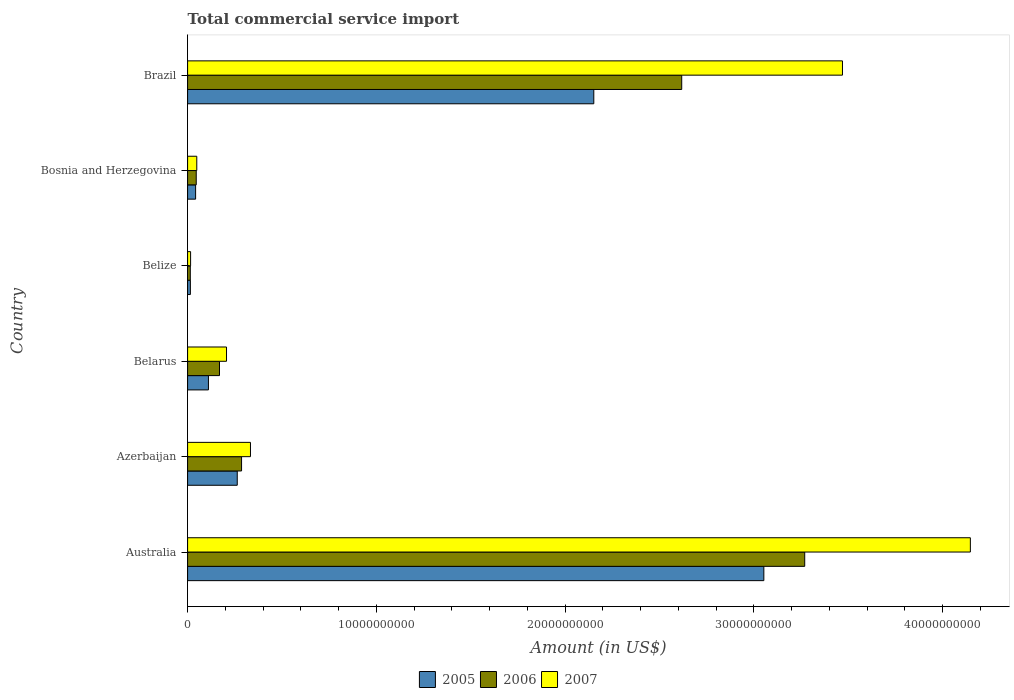How many different coloured bars are there?
Make the answer very short. 3. How many groups of bars are there?
Provide a succinct answer. 6. Are the number of bars on each tick of the Y-axis equal?
Provide a short and direct response. Yes. What is the label of the 2nd group of bars from the top?
Give a very brief answer. Bosnia and Herzegovina. What is the total commercial service import in 2007 in Brazil?
Offer a terse response. 3.47e+1. Across all countries, what is the maximum total commercial service import in 2005?
Ensure brevity in your answer.  3.05e+1. Across all countries, what is the minimum total commercial service import in 2006?
Provide a succinct answer. 1.43e+08. In which country was the total commercial service import in 2006 minimum?
Keep it short and to the point. Belize. What is the total total commercial service import in 2006 in the graph?
Offer a very short reply. 6.40e+1. What is the difference between the total commercial service import in 2005 in Azerbaijan and that in Belarus?
Provide a short and direct response. 1.53e+09. What is the difference between the total commercial service import in 2005 in Belize and the total commercial service import in 2006 in Australia?
Ensure brevity in your answer.  -3.26e+1. What is the average total commercial service import in 2005 per country?
Offer a terse response. 9.39e+09. What is the difference between the total commercial service import in 2007 and total commercial service import in 2005 in Australia?
Provide a succinct answer. 1.09e+1. What is the ratio of the total commercial service import in 2005 in Azerbaijan to that in Belarus?
Make the answer very short. 2.38. Is the total commercial service import in 2006 in Azerbaijan less than that in Bosnia and Herzegovina?
Your answer should be compact. No. What is the difference between the highest and the second highest total commercial service import in 2007?
Your answer should be compact. 6.78e+09. What is the difference between the highest and the lowest total commercial service import in 2007?
Offer a terse response. 4.13e+1. In how many countries, is the total commercial service import in 2006 greater than the average total commercial service import in 2006 taken over all countries?
Offer a terse response. 2. What does the 1st bar from the top in Azerbaijan represents?
Provide a succinct answer. 2007. What does the 3rd bar from the bottom in Bosnia and Herzegovina represents?
Offer a terse response. 2007. Is it the case that in every country, the sum of the total commercial service import in 2007 and total commercial service import in 2005 is greater than the total commercial service import in 2006?
Provide a succinct answer. Yes. How many bars are there?
Provide a short and direct response. 18. How many countries are there in the graph?
Your response must be concise. 6. Does the graph contain any zero values?
Your response must be concise. No. Does the graph contain grids?
Give a very brief answer. No. How are the legend labels stacked?
Your answer should be compact. Horizontal. What is the title of the graph?
Offer a very short reply. Total commercial service import. What is the Amount (in US$) of 2005 in Australia?
Make the answer very short. 3.05e+1. What is the Amount (in US$) in 2006 in Australia?
Your answer should be compact. 3.27e+1. What is the Amount (in US$) of 2007 in Australia?
Offer a very short reply. 4.15e+1. What is the Amount (in US$) of 2005 in Azerbaijan?
Keep it short and to the point. 2.63e+09. What is the Amount (in US$) in 2006 in Azerbaijan?
Make the answer very short. 2.86e+09. What is the Amount (in US$) of 2007 in Azerbaijan?
Provide a succinct answer. 3.33e+09. What is the Amount (in US$) of 2005 in Belarus?
Give a very brief answer. 1.10e+09. What is the Amount (in US$) in 2006 in Belarus?
Provide a short and direct response. 1.69e+09. What is the Amount (in US$) of 2007 in Belarus?
Give a very brief answer. 2.06e+09. What is the Amount (in US$) of 2005 in Belize?
Provide a short and direct response. 1.47e+08. What is the Amount (in US$) of 2006 in Belize?
Make the answer very short. 1.43e+08. What is the Amount (in US$) of 2007 in Belize?
Your answer should be compact. 1.59e+08. What is the Amount (in US$) in 2005 in Bosnia and Herzegovina?
Keep it short and to the point. 4.25e+08. What is the Amount (in US$) in 2006 in Bosnia and Herzegovina?
Offer a terse response. 4.58e+08. What is the Amount (in US$) of 2007 in Bosnia and Herzegovina?
Give a very brief answer. 4.87e+08. What is the Amount (in US$) of 2005 in Brazil?
Offer a very short reply. 2.15e+1. What is the Amount (in US$) of 2006 in Brazil?
Offer a very short reply. 2.62e+1. What is the Amount (in US$) of 2007 in Brazil?
Give a very brief answer. 3.47e+1. Across all countries, what is the maximum Amount (in US$) of 2005?
Your response must be concise. 3.05e+1. Across all countries, what is the maximum Amount (in US$) of 2006?
Ensure brevity in your answer.  3.27e+1. Across all countries, what is the maximum Amount (in US$) of 2007?
Your answer should be compact. 4.15e+1. Across all countries, what is the minimum Amount (in US$) in 2005?
Your answer should be compact. 1.47e+08. Across all countries, what is the minimum Amount (in US$) of 2006?
Your response must be concise. 1.43e+08. Across all countries, what is the minimum Amount (in US$) of 2007?
Ensure brevity in your answer.  1.59e+08. What is the total Amount (in US$) in 2005 in the graph?
Make the answer very short. 5.64e+1. What is the total Amount (in US$) in 2006 in the graph?
Ensure brevity in your answer.  6.40e+1. What is the total Amount (in US$) in 2007 in the graph?
Make the answer very short. 8.22e+1. What is the difference between the Amount (in US$) of 2005 in Australia and that in Azerbaijan?
Offer a terse response. 2.79e+1. What is the difference between the Amount (in US$) in 2006 in Australia and that in Azerbaijan?
Provide a short and direct response. 2.98e+1. What is the difference between the Amount (in US$) in 2007 in Australia and that in Azerbaijan?
Your answer should be compact. 3.81e+1. What is the difference between the Amount (in US$) in 2005 in Australia and that in Belarus?
Make the answer very short. 2.94e+1. What is the difference between the Amount (in US$) in 2006 in Australia and that in Belarus?
Ensure brevity in your answer.  3.10e+1. What is the difference between the Amount (in US$) of 2007 in Australia and that in Belarus?
Your response must be concise. 3.94e+1. What is the difference between the Amount (in US$) in 2005 in Australia and that in Belize?
Give a very brief answer. 3.04e+1. What is the difference between the Amount (in US$) of 2006 in Australia and that in Belize?
Provide a succinct answer. 3.26e+1. What is the difference between the Amount (in US$) of 2007 in Australia and that in Belize?
Offer a very short reply. 4.13e+1. What is the difference between the Amount (in US$) of 2005 in Australia and that in Bosnia and Herzegovina?
Keep it short and to the point. 3.01e+1. What is the difference between the Amount (in US$) in 2006 in Australia and that in Bosnia and Herzegovina?
Ensure brevity in your answer.  3.22e+1. What is the difference between the Amount (in US$) of 2007 in Australia and that in Bosnia and Herzegovina?
Give a very brief answer. 4.10e+1. What is the difference between the Amount (in US$) in 2005 in Australia and that in Brazil?
Offer a very short reply. 9.01e+09. What is the difference between the Amount (in US$) of 2006 in Australia and that in Brazil?
Offer a very short reply. 6.52e+09. What is the difference between the Amount (in US$) of 2007 in Australia and that in Brazil?
Offer a very short reply. 6.78e+09. What is the difference between the Amount (in US$) in 2005 in Azerbaijan and that in Belarus?
Offer a terse response. 1.53e+09. What is the difference between the Amount (in US$) in 2006 in Azerbaijan and that in Belarus?
Offer a very short reply. 1.17e+09. What is the difference between the Amount (in US$) in 2007 in Azerbaijan and that in Belarus?
Offer a very short reply. 1.27e+09. What is the difference between the Amount (in US$) in 2005 in Azerbaijan and that in Belize?
Offer a terse response. 2.48e+09. What is the difference between the Amount (in US$) in 2006 in Azerbaijan and that in Belize?
Ensure brevity in your answer.  2.72e+09. What is the difference between the Amount (in US$) in 2007 in Azerbaijan and that in Belize?
Make the answer very short. 3.17e+09. What is the difference between the Amount (in US$) of 2005 in Azerbaijan and that in Bosnia and Herzegovina?
Provide a succinct answer. 2.21e+09. What is the difference between the Amount (in US$) of 2006 in Azerbaijan and that in Bosnia and Herzegovina?
Keep it short and to the point. 2.40e+09. What is the difference between the Amount (in US$) in 2007 in Azerbaijan and that in Bosnia and Herzegovina?
Offer a very short reply. 2.84e+09. What is the difference between the Amount (in US$) in 2005 in Azerbaijan and that in Brazil?
Provide a short and direct response. -1.89e+1. What is the difference between the Amount (in US$) of 2006 in Azerbaijan and that in Brazil?
Your response must be concise. -2.33e+1. What is the difference between the Amount (in US$) in 2007 in Azerbaijan and that in Brazil?
Your answer should be compact. -3.14e+1. What is the difference between the Amount (in US$) of 2005 in Belarus and that in Belize?
Give a very brief answer. 9.57e+08. What is the difference between the Amount (in US$) of 2006 in Belarus and that in Belize?
Your answer should be very brief. 1.55e+09. What is the difference between the Amount (in US$) in 2007 in Belarus and that in Belize?
Your answer should be very brief. 1.90e+09. What is the difference between the Amount (in US$) in 2005 in Belarus and that in Bosnia and Herzegovina?
Your answer should be compact. 6.79e+08. What is the difference between the Amount (in US$) in 2006 in Belarus and that in Bosnia and Herzegovina?
Provide a succinct answer. 1.23e+09. What is the difference between the Amount (in US$) in 2007 in Belarus and that in Bosnia and Herzegovina?
Make the answer very short. 1.58e+09. What is the difference between the Amount (in US$) in 2005 in Belarus and that in Brazil?
Make the answer very short. -2.04e+1. What is the difference between the Amount (in US$) of 2006 in Belarus and that in Brazil?
Your response must be concise. -2.45e+1. What is the difference between the Amount (in US$) in 2007 in Belarus and that in Brazil?
Keep it short and to the point. -3.26e+1. What is the difference between the Amount (in US$) in 2005 in Belize and that in Bosnia and Herzegovina?
Provide a succinct answer. -2.78e+08. What is the difference between the Amount (in US$) of 2006 in Belize and that in Bosnia and Herzegovina?
Your answer should be very brief. -3.15e+08. What is the difference between the Amount (in US$) in 2007 in Belize and that in Bosnia and Herzegovina?
Ensure brevity in your answer.  -3.28e+08. What is the difference between the Amount (in US$) of 2005 in Belize and that in Brazil?
Give a very brief answer. -2.14e+1. What is the difference between the Amount (in US$) of 2006 in Belize and that in Brazil?
Offer a terse response. -2.60e+1. What is the difference between the Amount (in US$) of 2007 in Belize and that in Brazil?
Give a very brief answer. -3.45e+1. What is the difference between the Amount (in US$) of 2005 in Bosnia and Herzegovina and that in Brazil?
Keep it short and to the point. -2.11e+1. What is the difference between the Amount (in US$) in 2006 in Bosnia and Herzegovina and that in Brazil?
Ensure brevity in your answer.  -2.57e+1. What is the difference between the Amount (in US$) of 2007 in Bosnia and Herzegovina and that in Brazil?
Your response must be concise. -3.42e+1. What is the difference between the Amount (in US$) in 2005 in Australia and the Amount (in US$) in 2006 in Azerbaijan?
Your answer should be compact. 2.77e+1. What is the difference between the Amount (in US$) of 2005 in Australia and the Amount (in US$) of 2007 in Azerbaijan?
Offer a very short reply. 2.72e+1. What is the difference between the Amount (in US$) of 2006 in Australia and the Amount (in US$) of 2007 in Azerbaijan?
Your answer should be very brief. 2.94e+1. What is the difference between the Amount (in US$) in 2005 in Australia and the Amount (in US$) in 2006 in Belarus?
Your response must be concise. 2.88e+1. What is the difference between the Amount (in US$) of 2005 in Australia and the Amount (in US$) of 2007 in Belarus?
Keep it short and to the point. 2.85e+1. What is the difference between the Amount (in US$) in 2006 in Australia and the Amount (in US$) in 2007 in Belarus?
Your response must be concise. 3.06e+1. What is the difference between the Amount (in US$) in 2005 in Australia and the Amount (in US$) in 2006 in Belize?
Your answer should be compact. 3.04e+1. What is the difference between the Amount (in US$) of 2005 in Australia and the Amount (in US$) of 2007 in Belize?
Keep it short and to the point. 3.04e+1. What is the difference between the Amount (in US$) of 2006 in Australia and the Amount (in US$) of 2007 in Belize?
Your response must be concise. 3.25e+1. What is the difference between the Amount (in US$) in 2005 in Australia and the Amount (in US$) in 2006 in Bosnia and Herzegovina?
Keep it short and to the point. 3.01e+1. What is the difference between the Amount (in US$) of 2005 in Australia and the Amount (in US$) of 2007 in Bosnia and Herzegovina?
Keep it short and to the point. 3.00e+1. What is the difference between the Amount (in US$) in 2006 in Australia and the Amount (in US$) in 2007 in Bosnia and Herzegovina?
Give a very brief answer. 3.22e+1. What is the difference between the Amount (in US$) of 2005 in Australia and the Amount (in US$) of 2006 in Brazil?
Give a very brief answer. 4.35e+09. What is the difference between the Amount (in US$) in 2005 in Australia and the Amount (in US$) in 2007 in Brazil?
Offer a terse response. -4.17e+09. What is the difference between the Amount (in US$) in 2006 in Australia and the Amount (in US$) in 2007 in Brazil?
Your answer should be compact. -2.00e+09. What is the difference between the Amount (in US$) of 2005 in Azerbaijan and the Amount (in US$) of 2006 in Belarus?
Offer a very short reply. 9.40e+08. What is the difference between the Amount (in US$) in 2005 in Azerbaijan and the Amount (in US$) in 2007 in Belarus?
Your answer should be very brief. 5.68e+08. What is the difference between the Amount (in US$) in 2006 in Azerbaijan and the Amount (in US$) in 2007 in Belarus?
Offer a very short reply. 7.97e+08. What is the difference between the Amount (in US$) of 2005 in Azerbaijan and the Amount (in US$) of 2006 in Belize?
Provide a succinct answer. 2.49e+09. What is the difference between the Amount (in US$) in 2005 in Azerbaijan and the Amount (in US$) in 2007 in Belize?
Provide a succinct answer. 2.47e+09. What is the difference between the Amount (in US$) of 2006 in Azerbaijan and the Amount (in US$) of 2007 in Belize?
Provide a succinct answer. 2.70e+09. What is the difference between the Amount (in US$) of 2005 in Azerbaijan and the Amount (in US$) of 2006 in Bosnia and Herzegovina?
Your answer should be very brief. 2.17e+09. What is the difference between the Amount (in US$) in 2005 in Azerbaijan and the Amount (in US$) in 2007 in Bosnia and Herzegovina?
Offer a very short reply. 2.14e+09. What is the difference between the Amount (in US$) of 2006 in Azerbaijan and the Amount (in US$) of 2007 in Bosnia and Herzegovina?
Keep it short and to the point. 2.37e+09. What is the difference between the Amount (in US$) of 2005 in Azerbaijan and the Amount (in US$) of 2006 in Brazil?
Ensure brevity in your answer.  -2.36e+1. What is the difference between the Amount (in US$) of 2005 in Azerbaijan and the Amount (in US$) of 2007 in Brazil?
Give a very brief answer. -3.21e+1. What is the difference between the Amount (in US$) of 2006 in Azerbaijan and the Amount (in US$) of 2007 in Brazil?
Make the answer very short. -3.18e+1. What is the difference between the Amount (in US$) in 2005 in Belarus and the Amount (in US$) in 2006 in Belize?
Give a very brief answer. 9.61e+08. What is the difference between the Amount (in US$) of 2005 in Belarus and the Amount (in US$) of 2007 in Belize?
Keep it short and to the point. 9.45e+08. What is the difference between the Amount (in US$) of 2006 in Belarus and the Amount (in US$) of 2007 in Belize?
Keep it short and to the point. 1.53e+09. What is the difference between the Amount (in US$) of 2005 in Belarus and the Amount (in US$) of 2006 in Bosnia and Herzegovina?
Provide a short and direct response. 6.46e+08. What is the difference between the Amount (in US$) of 2005 in Belarus and the Amount (in US$) of 2007 in Bosnia and Herzegovina?
Keep it short and to the point. 6.18e+08. What is the difference between the Amount (in US$) of 2006 in Belarus and the Amount (in US$) of 2007 in Bosnia and Herzegovina?
Keep it short and to the point. 1.20e+09. What is the difference between the Amount (in US$) in 2005 in Belarus and the Amount (in US$) in 2006 in Brazil?
Your answer should be very brief. -2.51e+1. What is the difference between the Amount (in US$) in 2005 in Belarus and the Amount (in US$) in 2007 in Brazil?
Your response must be concise. -3.36e+1. What is the difference between the Amount (in US$) of 2006 in Belarus and the Amount (in US$) of 2007 in Brazil?
Keep it short and to the point. -3.30e+1. What is the difference between the Amount (in US$) of 2005 in Belize and the Amount (in US$) of 2006 in Bosnia and Herzegovina?
Provide a succinct answer. -3.11e+08. What is the difference between the Amount (in US$) of 2005 in Belize and the Amount (in US$) of 2007 in Bosnia and Herzegovina?
Give a very brief answer. -3.39e+08. What is the difference between the Amount (in US$) of 2006 in Belize and the Amount (in US$) of 2007 in Bosnia and Herzegovina?
Your response must be concise. -3.43e+08. What is the difference between the Amount (in US$) of 2005 in Belize and the Amount (in US$) of 2006 in Brazil?
Give a very brief answer. -2.60e+1. What is the difference between the Amount (in US$) of 2005 in Belize and the Amount (in US$) of 2007 in Brazil?
Offer a very short reply. -3.46e+1. What is the difference between the Amount (in US$) in 2006 in Belize and the Amount (in US$) in 2007 in Brazil?
Ensure brevity in your answer.  -3.46e+1. What is the difference between the Amount (in US$) of 2005 in Bosnia and Herzegovina and the Amount (in US$) of 2006 in Brazil?
Your response must be concise. -2.58e+1. What is the difference between the Amount (in US$) in 2005 in Bosnia and Herzegovina and the Amount (in US$) in 2007 in Brazil?
Your answer should be compact. -3.43e+1. What is the difference between the Amount (in US$) of 2006 in Bosnia and Herzegovina and the Amount (in US$) of 2007 in Brazil?
Make the answer very short. -3.42e+1. What is the average Amount (in US$) in 2005 per country?
Your answer should be very brief. 9.39e+09. What is the average Amount (in US$) of 2006 per country?
Ensure brevity in your answer.  1.07e+1. What is the average Amount (in US$) in 2007 per country?
Make the answer very short. 1.37e+1. What is the difference between the Amount (in US$) of 2005 and Amount (in US$) of 2006 in Australia?
Provide a succinct answer. -2.17e+09. What is the difference between the Amount (in US$) in 2005 and Amount (in US$) in 2007 in Australia?
Your response must be concise. -1.09e+1. What is the difference between the Amount (in US$) of 2006 and Amount (in US$) of 2007 in Australia?
Keep it short and to the point. -8.78e+09. What is the difference between the Amount (in US$) of 2005 and Amount (in US$) of 2006 in Azerbaijan?
Provide a succinct answer. -2.28e+08. What is the difference between the Amount (in US$) of 2005 and Amount (in US$) of 2007 in Azerbaijan?
Give a very brief answer. -7.00e+08. What is the difference between the Amount (in US$) of 2006 and Amount (in US$) of 2007 in Azerbaijan?
Give a very brief answer. -4.72e+08. What is the difference between the Amount (in US$) of 2005 and Amount (in US$) of 2006 in Belarus?
Keep it short and to the point. -5.87e+08. What is the difference between the Amount (in US$) of 2005 and Amount (in US$) of 2007 in Belarus?
Your answer should be compact. -9.58e+08. What is the difference between the Amount (in US$) of 2006 and Amount (in US$) of 2007 in Belarus?
Offer a very short reply. -3.72e+08. What is the difference between the Amount (in US$) of 2005 and Amount (in US$) of 2006 in Belize?
Offer a very short reply. 3.89e+06. What is the difference between the Amount (in US$) of 2005 and Amount (in US$) of 2007 in Belize?
Keep it short and to the point. -1.18e+07. What is the difference between the Amount (in US$) of 2006 and Amount (in US$) of 2007 in Belize?
Your response must be concise. -1.57e+07. What is the difference between the Amount (in US$) of 2005 and Amount (in US$) of 2006 in Bosnia and Herzegovina?
Make the answer very short. -3.32e+07. What is the difference between the Amount (in US$) in 2005 and Amount (in US$) in 2007 in Bosnia and Herzegovina?
Provide a succinct answer. -6.18e+07. What is the difference between the Amount (in US$) of 2006 and Amount (in US$) of 2007 in Bosnia and Herzegovina?
Offer a very short reply. -2.86e+07. What is the difference between the Amount (in US$) of 2005 and Amount (in US$) of 2006 in Brazil?
Provide a succinct answer. -4.66e+09. What is the difference between the Amount (in US$) in 2005 and Amount (in US$) in 2007 in Brazil?
Give a very brief answer. -1.32e+1. What is the difference between the Amount (in US$) of 2006 and Amount (in US$) of 2007 in Brazil?
Make the answer very short. -8.52e+09. What is the ratio of the Amount (in US$) of 2005 in Australia to that in Azerbaijan?
Your answer should be very brief. 11.61. What is the ratio of the Amount (in US$) of 2006 in Australia to that in Azerbaijan?
Your answer should be compact. 11.44. What is the ratio of the Amount (in US$) of 2007 in Australia to that in Azerbaijan?
Give a very brief answer. 12.45. What is the ratio of the Amount (in US$) of 2005 in Australia to that in Belarus?
Keep it short and to the point. 27.65. What is the ratio of the Amount (in US$) of 2006 in Australia to that in Belarus?
Ensure brevity in your answer.  19.34. What is the ratio of the Amount (in US$) of 2007 in Australia to that in Belarus?
Offer a very short reply. 20.11. What is the ratio of the Amount (in US$) of 2005 in Australia to that in Belize?
Keep it short and to the point. 207.45. What is the ratio of the Amount (in US$) in 2006 in Australia to that in Belize?
Your answer should be compact. 228.19. What is the ratio of the Amount (in US$) of 2007 in Australia to that in Belize?
Make the answer very short. 260.86. What is the ratio of the Amount (in US$) in 2005 in Australia to that in Bosnia and Herzegovina?
Keep it short and to the point. 71.87. What is the ratio of the Amount (in US$) in 2006 in Australia to that in Bosnia and Herzegovina?
Your answer should be compact. 71.39. What is the ratio of the Amount (in US$) in 2007 in Australia to that in Bosnia and Herzegovina?
Keep it short and to the point. 85.23. What is the ratio of the Amount (in US$) in 2005 in Australia to that in Brazil?
Your answer should be compact. 1.42. What is the ratio of the Amount (in US$) in 2006 in Australia to that in Brazil?
Offer a very short reply. 1.25. What is the ratio of the Amount (in US$) of 2007 in Australia to that in Brazil?
Your answer should be very brief. 1.2. What is the ratio of the Amount (in US$) of 2005 in Azerbaijan to that in Belarus?
Ensure brevity in your answer.  2.38. What is the ratio of the Amount (in US$) of 2006 in Azerbaijan to that in Belarus?
Provide a short and direct response. 1.69. What is the ratio of the Amount (in US$) in 2007 in Azerbaijan to that in Belarus?
Your response must be concise. 1.61. What is the ratio of the Amount (in US$) in 2005 in Azerbaijan to that in Belize?
Ensure brevity in your answer.  17.87. What is the ratio of the Amount (in US$) of 2006 in Azerbaijan to that in Belize?
Give a very brief answer. 19.95. What is the ratio of the Amount (in US$) of 2007 in Azerbaijan to that in Belize?
Offer a terse response. 20.95. What is the ratio of the Amount (in US$) in 2005 in Azerbaijan to that in Bosnia and Herzegovina?
Provide a short and direct response. 6.19. What is the ratio of the Amount (in US$) in 2006 in Azerbaijan to that in Bosnia and Herzegovina?
Keep it short and to the point. 6.24. What is the ratio of the Amount (in US$) in 2007 in Azerbaijan to that in Bosnia and Herzegovina?
Your response must be concise. 6.85. What is the ratio of the Amount (in US$) in 2005 in Azerbaijan to that in Brazil?
Give a very brief answer. 0.12. What is the ratio of the Amount (in US$) of 2006 in Azerbaijan to that in Brazil?
Offer a very short reply. 0.11. What is the ratio of the Amount (in US$) of 2007 in Azerbaijan to that in Brazil?
Provide a succinct answer. 0.1. What is the ratio of the Amount (in US$) in 2005 in Belarus to that in Belize?
Your answer should be compact. 7.5. What is the ratio of the Amount (in US$) in 2006 in Belarus to that in Belize?
Give a very brief answer. 11.8. What is the ratio of the Amount (in US$) of 2007 in Belarus to that in Belize?
Offer a very short reply. 12.97. What is the ratio of the Amount (in US$) in 2005 in Belarus to that in Bosnia and Herzegovina?
Offer a very short reply. 2.6. What is the ratio of the Amount (in US$) of 2006 in Belarus to that in Bosnia and Herzegovina?
Keep it short and to the point. 3.69. What is the ratio of the Amount (in US$) in 2007 in Belarus to that in Bosnia and Herzegovina?
Make the answer very short. 4.24. What is the ratio of the Amount (in US$) of 2005 in Belarus to that in Brazil?
Ensure brevity in your answer.  0.05. What is the ratio of the Amount (in US$) of 2006 in Belarus to that in Brazil?
Provide a succinct answer. 0.06. What is the ratio of the Amount (in US$) of 2007 in Belarus to that in Brazil?
Your answer should be compact. 0.06. What is the ratio of the Amount (in US$) in 2005 in Belize to that in Bosnia and Herzegovina?
Your answer should be compact. 0.35. What is the ratio of the Amount (in US$) of 2006 in Belize to that in Bosnia and Herzegovina?
Keep it short and to the point. 0.31. What is the ratio of the Amount (in US$) in 2007 in Belize to that in Bosnia and Herzegovina?
Provide a short and direct response. 0.33. What is the ratio of the Amount (in US$) of 2005 in Belize to that in Brazil?
Give a very brief answer. 0.01. What is the ratio of the Amount (in US$) of 2006 in Belize to that in Brazil?
Offer a very short reply. 0.01. What is the ratio of the Amount (in US$) in 2007 in Belize to that in Brazil?
Your answer should be compact. 0. What is the ratio of the Amount (in US$) in 2005 in Bosnia and Herzegovina to that in Brazil?
Ensure brevity in your answer.  0.02. What is the ratio of the Amount (in US$) of 2006 in Bosnia and Herzegovina to that in Brazil?
Provide a short and direct response. 0.02. What is the ratio of the Amount (in US$) of 2007 in Bosnia and Herzegovina to that in Brazil?
Give a very brief answer. 0.01. What is the difference between the highest and the second highest Amount (in US$) of 2005?
Provide a succinct answer. 9.01e+09. What is the difference between the highest and the second highest Amount (in US$) in 2006?
Keep it short and to the point. 6.52e+09. What is the difference between the highest and the second highest Amount (in US$) in 2007?
Offer a very short reply. 6.78e+09. What is the difference between the highest and the lowest Amount (in US$) of 2005?
Provide a short and direct response. 3.04e+1. What is the difference between the highest and the lowest Amount (in US$) of 2006?
Your answer should be compact. 3.26e+1. What is the difference between the highest and the lowest Amount (in US$) in 2007?
Your answer should be compact. 4.13e+1. 